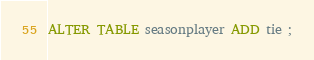Convert code to text. <code><loc_0><loc_0><loc_500><loc_500><_SQL_>ALTER TABLE seasonplayer ADD tie ;
</code> 